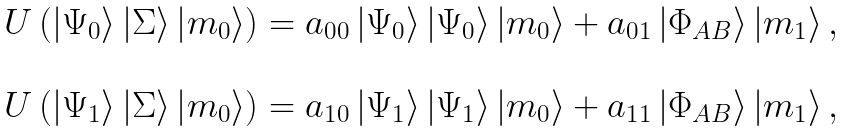<formula> <loc_0><loc_0><loc_500><loc_500>\begin{array} { c } U \left ( \left | \Psi _ { 0 } \right \rangle \left | \Sigma \right \rangle \left | m _ { 0 } \right \rangle \right ) = a _ { 0 0 } \left | \Psi _ { 0 } \right \rangle \left | \Psi _ { 0 } \right \rangle \left | m _ { 0 } \right \rangle + a _ { 0 1 } \left | \Phi _ { A B } \right \rangle \left | m _ { 1 } \right \rangle , \\ \\ U \left ( \left | \Psi _ { 1 } \right \rangle \left | \Sigma \right \rangle \left | m _ { 0 } \right \rangle \right ) = a _ { 1 0 } \left | \Psi _ { 1 } \right \rangle \left | \Psi _ { 1 } \right \rangle \left | m _ { 0 } \right \rangle + a _ { 1 1 } \left | \Phi _ { A B } \right \rangle \left | m _ { 1 } \right \rangle , \end{array}</formula> 